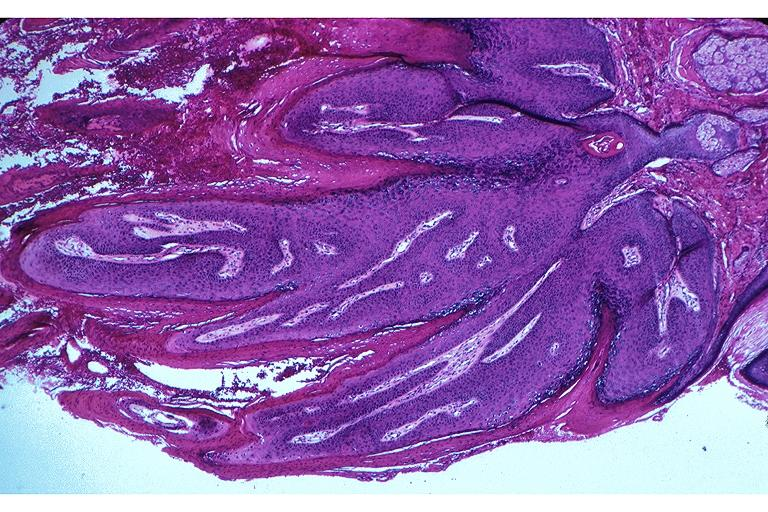s oral present?
Answer the question using a single word or phrase. Yes 